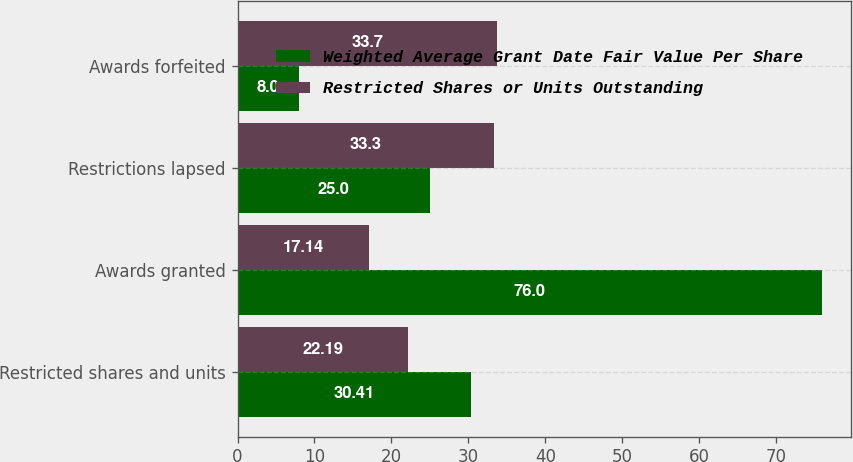<chart> <loc_0><loc_0><loc_500><loc_500><stacked_bar_chart><ecel><fcel>Restricted shares and units<fcel>Awards granted<fcel>Restrictions lapsed<fcel>Awards forfeited<nl><fcel>Weighted Average Grant Date Fair Value Per Share<fcel>30.41<fcel>76<fcel>25<fcel>8<nl><fcel>Restricted Shares or Units Outstanding<fcel>22.19<fcel>17.14<fcel>33.3<fcel>33.7<nl></chart> 